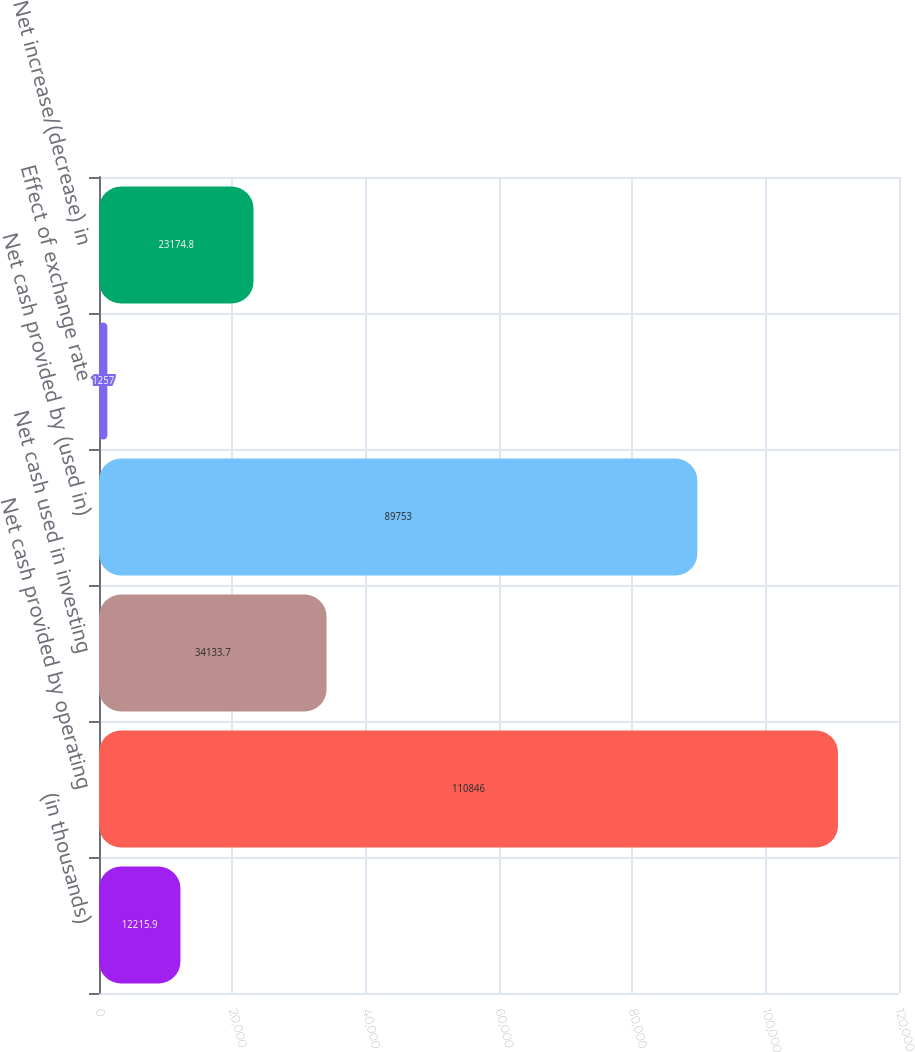Convert chart. <chart><loc_0><loc_0><loc_500><loc_500><bar_chart><fcel>(in thousands)<fcel>Net cash provided by operating<fcel>Net cash used in investing<fcel>Net cash provided by (used in)<fcel>Effect of exchange rate<fcel>Net increase/(decrease) in<nl><fcel>12215.9<fcel>110846<fcel>34133.7<fcel>89753<fcel>1257<fcel>23174.8<nl></chart> 